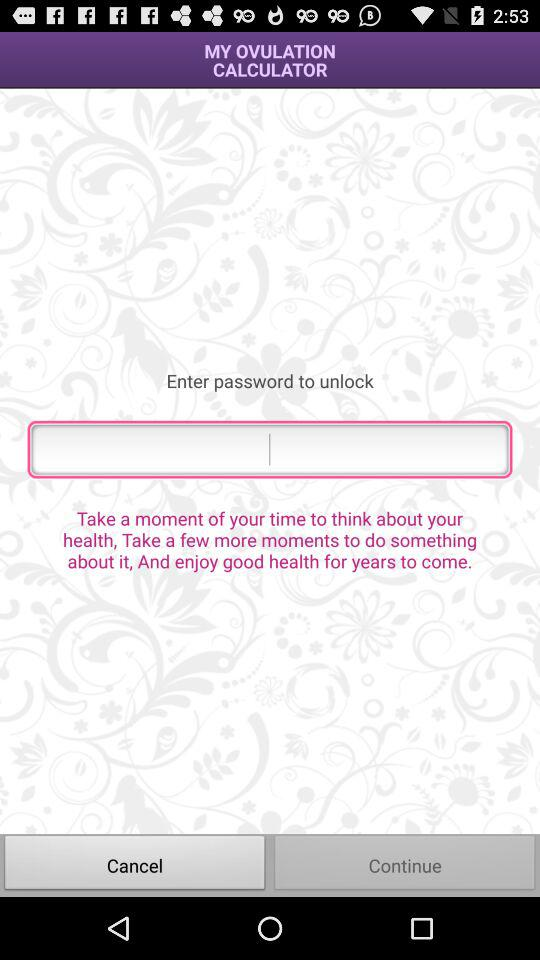Which button is selected?
When the provided information is insufficient, respond with <no answer>. <no answer> 